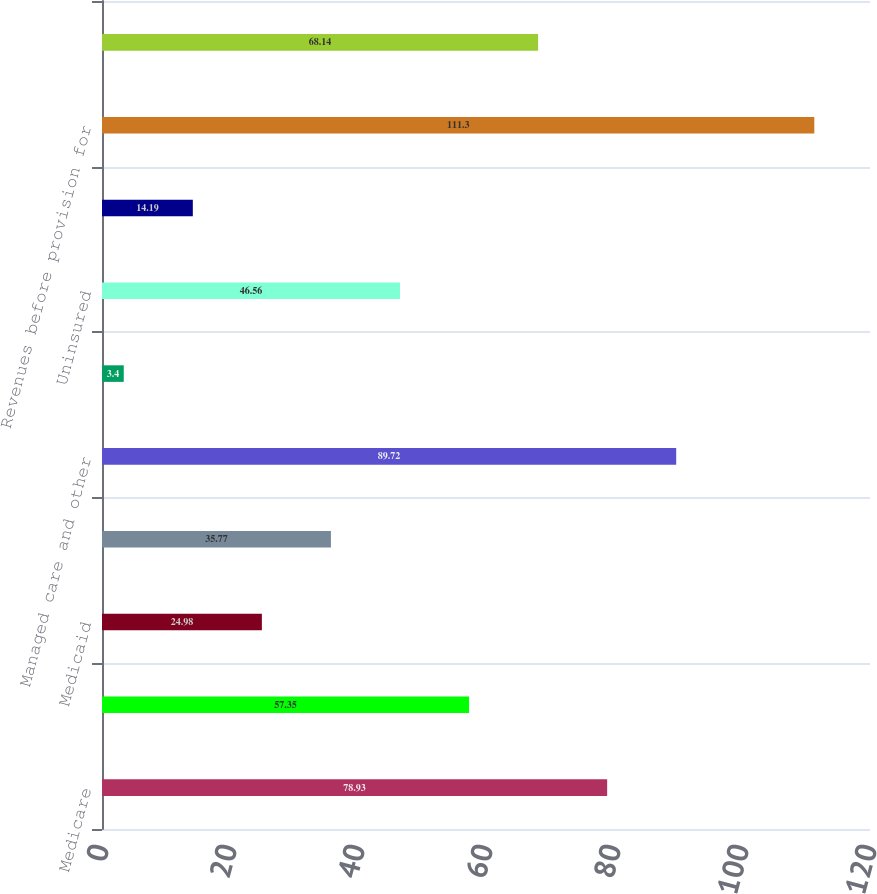Convert chart to OTSL. <chart><loc_0><loc_0><loc_500><loc_500><bar_chart><fcel>Medicare<fcel>Managed Medicare<fcel>Medicaid<fcel>Managed Medicaid<fcel>Managed care and other<fcel>International (managed care<fcel>Uninsured<fcel>Other<fcel>Revenues before provision for<fcel>Provision for doubtful<nl><fcel>78.93<fcel>57.35<fcel>24.98<fcel>35.77<fcel>89.72<fcel>3.4<fcel>46.56<fcel>14.19<fcel>111.3<fcel>68.14<nl></chart> 